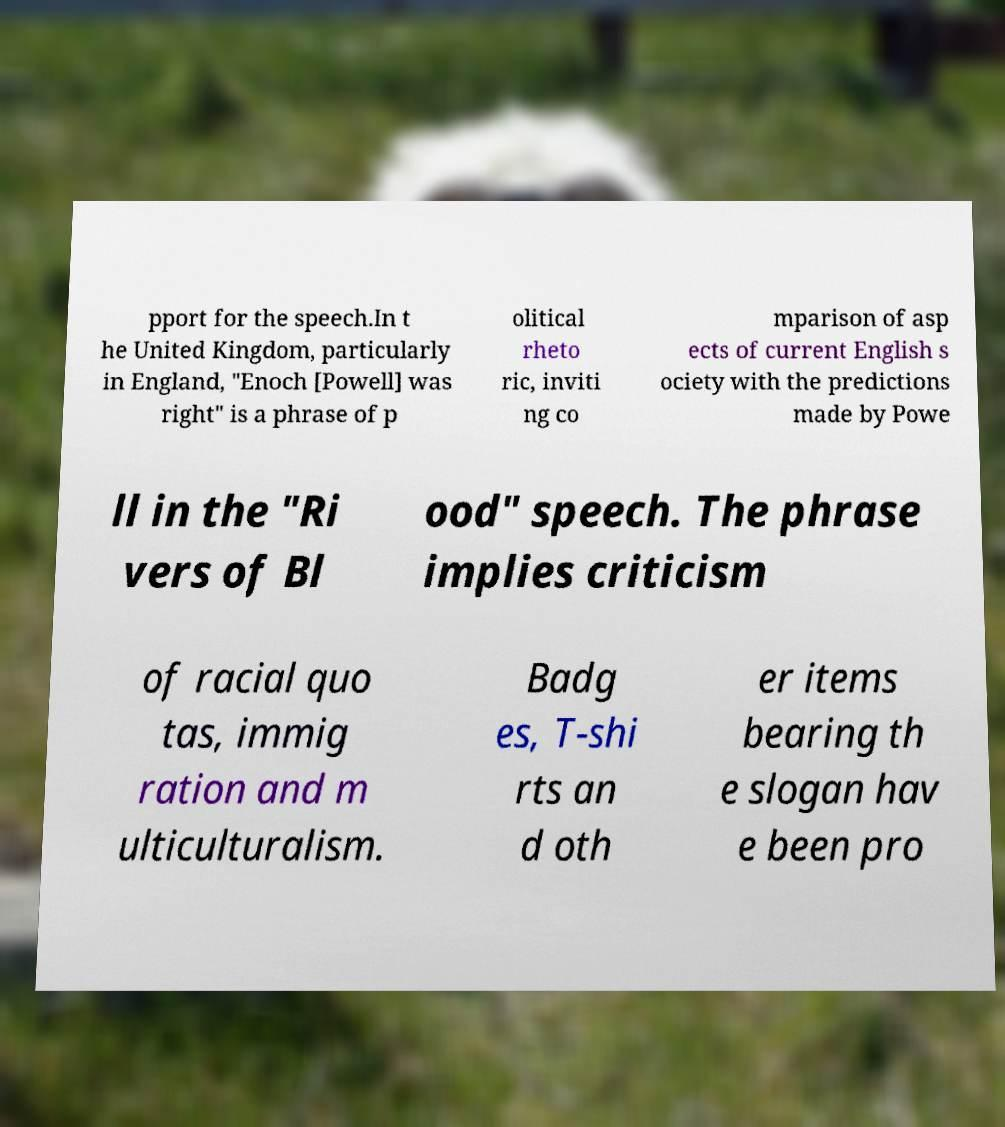What messages or text are displayed in this image? I need them in a readable, typed format. pport for the speech.In t he United Kingdom, particularly in England, "Enoch [Powell] was right" is a phrase of p olitical rheto ric, inviti ng co mparison of asp ects of current English s ociety with the predictions made by Powe ll in the "Ri vers of Bl ood" speech. The phrase implies criticism of racial quo tas, immig ration and m ulticulturalism. Badg es, T-shi rts an d oth er items bearing th e slogan hav e been pro 